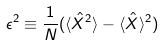<formula> <loc_0><loc_0><loc_500><loc_500>\epsilon ^ { 2 } \equiv \frac { 1 } { N } ( \langle \hat { X } ^ { 2 } \rangle - \langle \hat { X } \rangle ^ { 2 } )</formula> 